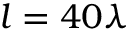<formula> <loc_0><loc_0><loc_500><loc_500>l = 4 0 \lambda</formula> 